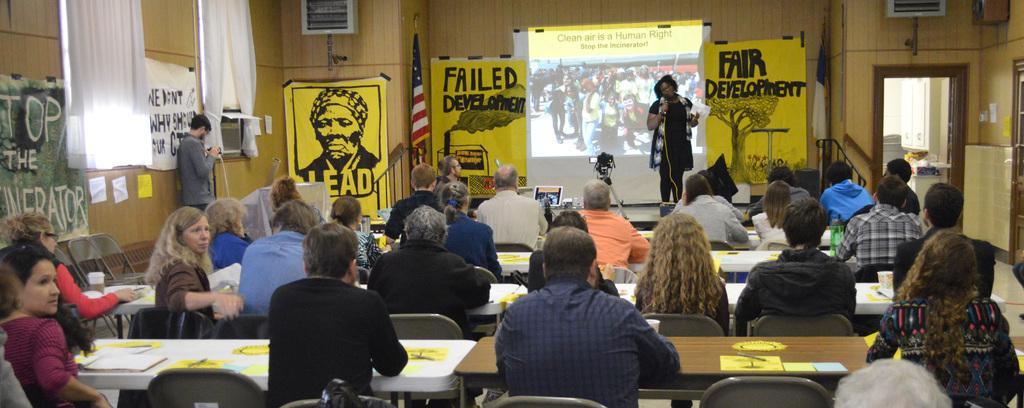Could you give a brief overview of what you see in this image? In this image I see number of people in which most of them are sitting on chairs and there are tables in front of them on which there are few things and I see that these 2 are standing and holding things in their hands and on the wall I see banners and posters and I see a flag over her and I can also see a projector screen over here and I see words written on the screen and posters and I see the white cloth over here and I can also see another flag over here. 